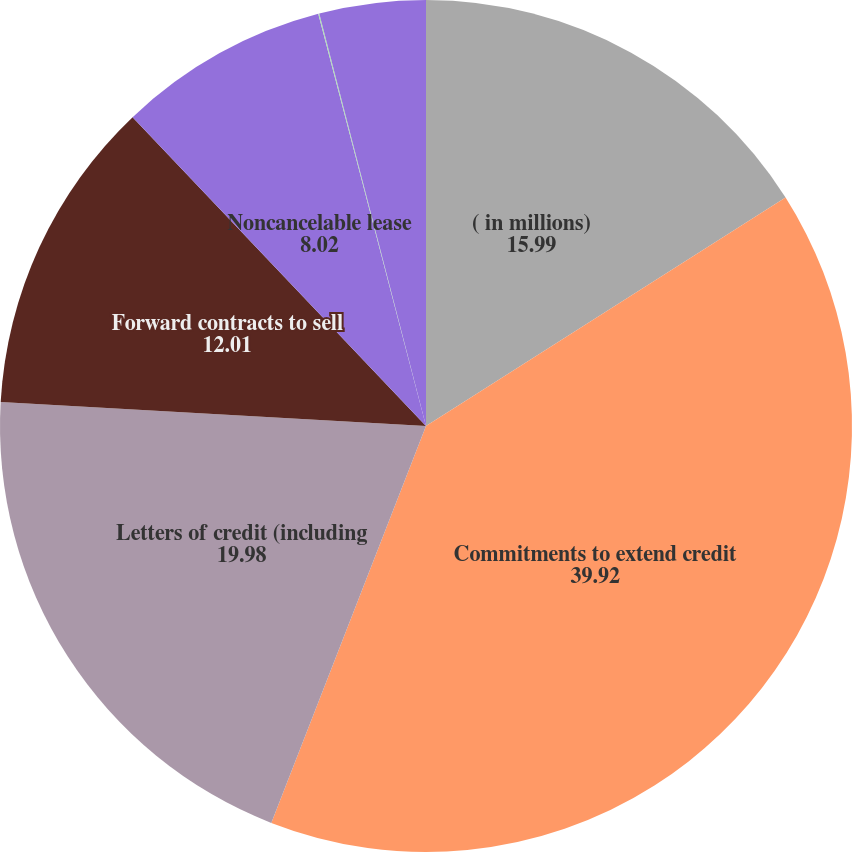<chart> <loc_0><loc_0><loc_500><loc_500><pie_chart><fcel>( in millions)<fcel>Commitments to extend credit<fcel>Letters of credit (including<fcel>Forward contracts to sell<fcel>Noncancelable lease<fcel>Purchase obligations<fcel>Capital expenditures<nl><fcel>15.99%<fcel>39.92%<fcel>19.98%<fcel>12.01%<fcel>8.02%<fcel>0.04%<fcel>4.03%<nl></chart> 